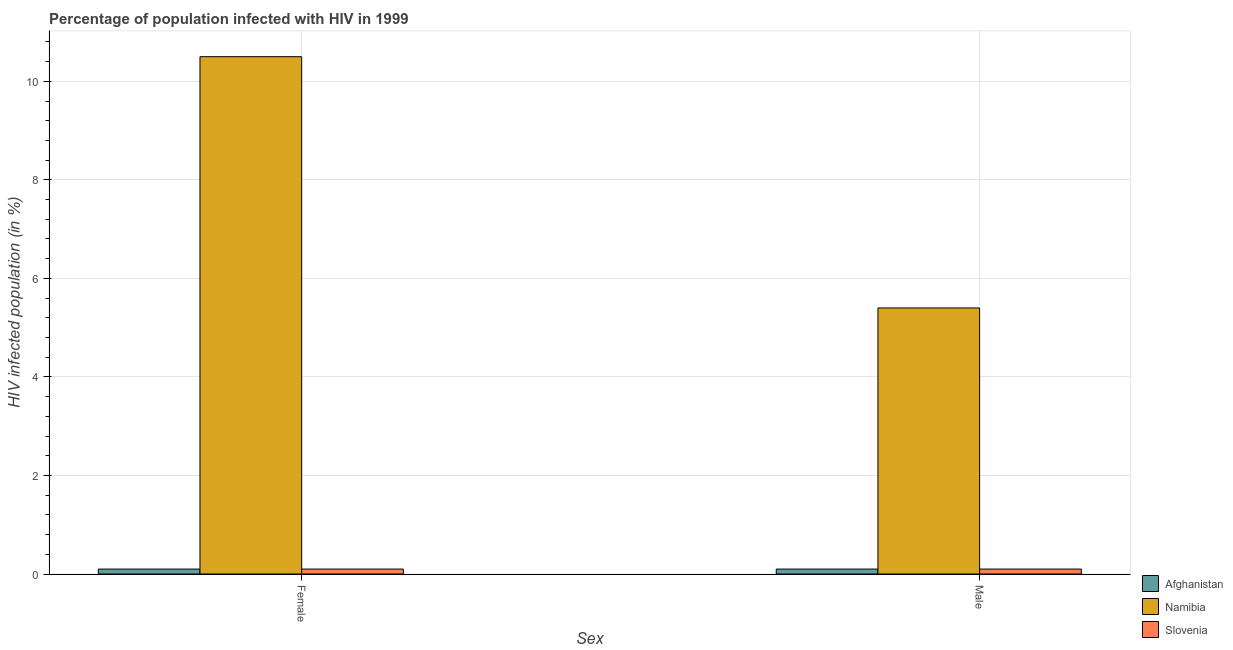How many different coloured bars are there?
Offer a very short reply. 3. How many groups of bars are there?
Make the answer very short. 2. Are the number of bars on each tick of the X-axis equal?
Your answer should be very brief. Yes. What is the percentage of females who are infected with hiv in Namibia?
Give a very brief answer. 10.5. Across all countries, what is the maximum percentage of females who are infected with hiv?
Make the answer very short. 10.5. In which country was the percentage of females who are infected with hiv maximum?
Give a very brief answer. Namibia. In which country was the percentage of females who are infected with hiv minimum?
Provide a short and direct response. Afghanistan. What is the total percentage of females who are infected with hiv in the graph?
Provide a succinct answer. 10.7. What is the difference between the percentage of males who are infected with hiv in Afghanistan and the percentage of females who are infected with hiv in Slovenia?
Your answer should be compact. 0. What is the average percentage of females who are infected with hiv per country?
Give a very brief answer. 3.57. What is the difference between the percentage of females who are infected with hiv and percentage of males who are infected with hiv in Namibia?
Your answer should be very brief. 5.1. What is the ratio of the percentage of females who are infected with hiv in Namibia to that in Afghanistan?
Make the answer very short. 105. Is the percentage of males who are infected with hiv in Slovenia less than that in Namibia?
Offer a very short reply. Yes. In how many countries, is the percentage of females who are infected with hiv greater than the average percentage of females who are infected with hiv taken over all countries?
Provide a short and direct response. 1. What does the 3rd bar from the left in Female represents?
Give a very brief answer. Slovenia. What does the 3rd bar from the right in Male represents?
Offer a very short reply. Afghanistan. Are all the bars in the graph horizontal?
Your answer should be very brief. No. What is the difference between two consecutive major ticks on the Y-axis?
Ensure brevity in your answer.  2. Are the values on the major ticks of Y-axis written in scientific E-notation?
Offer a very short reply. No. Does the graph contain grids?
Make the answer very short. Yes. How many legend labels are there?
Offer a very short reply. 3. What is the title of the graph?
Offer a terse response. Percentage of population infected with HIV in 1999. What is the label or title of the X-axis?
Provide a succinct answer. Sex. What is the label or title of the Y-axis?
Your answer should be very brief. HIV infected population (in %). What is the HIV infected population (in %) of Afghanistan in Female?
Provide a short and direct response. 0.1. What is the HIV infected population (in %) of Namibia in Female?
Make the answer very short. 10.5. What is the HIV infected population (in %) of Slovenia in Female?
Keep it short and to the point. 0.1. What is the HIV infected population (in %) of Afghanistan in Male?
Your answer should be compact. 0.1. Across all Sex, what is the maximum HIV infected population (in %) of Slovenia?
Make the answer very short. 0.1. Across all Sex, what is the minimum HIV infected population (in %) of Afghanistan?
Make the answer very short. 0.1. Across all Sex, what is the minimum HIV infected population (in %) of Slovenia?
Provide a short and direct response. 0.1. What is the total HIV infected population (in %) in Afghanistan in the graph?
Your answer should be compact. 0.2. What is the total HIV infected population (in %) in Namibia in the graph?
Ensure brevity in your answer.  15.9. What is the difference between the HIV infected population (in %) in Afghanistan in Female and the HIV infected population (in %) in Namibia in Male?
Make the answer very short. -5.3. What is the difference between the HIV infected population (in %) of Namibia in Female and the HIV infected population (in %) of Slovenia in Male?
Your answer should be very brief. 10.4. What is the average HIV infected population (in %) of Afghanistan per Sex?
Your answer should be very brief. 0.1. What is the average HIV infected population (in %) in Namibia per Sex?
Ensure brevity in your answer.  7.95. What is the average HIV infected population (in %) of Slovenia per Sex?
Keep it short and to the point. 0.1. What is the ratio of the HIV infected population (in %) of Namibia in Female to that in Male?
Make the answer very short. 1.94. What is the ratio of the HIV infected population (in %) in Slovenia in Female to that in Male?
Provide a short and direct response. 1. What is the difference between the highest and the second highest HIV infected population (in %) of Afghanistan?
Provide a succinct answer. 0. What is the difference between the highest and the second highest HIV infected population (in %) in Namibia?
Offer a terse response. 5.1. What is the difference between the highest and the second highest HIV infected population (in %) in Slovenia?
Provide a short and direct response. 0. 